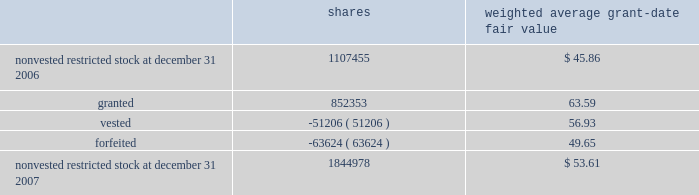Humana inc .
Notes to consolidated financial statements 2014 ( continued ) the total intrinsic value of stock options exercised during 2007 was $ 133.9 million , compared with $ 133.7 million during 2006 and $ 57.8 million during 2005 .
Cash received from stock option exercises for the years ended december 31 , 2007 , 2006 , and 2005 totaled $ 62.7 million , $ 49.2 million , and $ 36.4 million , respectively .
Total compensation expense related to nonvested options not yet recognized was $ 23.6 million at december 31 , 2007 .
We expect to recognize this compensation expense over a weighted average period of approximately 1.6 years .
Restricted stock awards restricted stock awards are granted with a fair value equal to the market price of our common stock on the date of grant .
Compensation expense is recorded straight-line over the vesting period , generally three years from the date of grant .
The weighted average grant date fair value of our restricted stock awards was $ 63.59 , $ 54.36 , and $ 32.81 for the years ended december 31 , 2007 , 2006 , and 2005 , respectively .
Activity for our restricted stock awards was as follows for the year ended december 31 , 2007 : shares weighted average grant-date fair value .
The fair value of shares vested during the years ended december 31 , 2007 , 2006 , and 2005 was $ 3.4 million , $ 2.3 million , and $ 0.6 million , respectively .
Total compensation expense related to nonvested restricted stock awards not yet recognized was $ 44.7 million at december 31 , 2007 .
We expect to recognize this compensation expense over a weighted average period of approximately 1.4 years .
There are no other contractual terms covering restricted stock awards once vested. .
For the year ended december 31 , 2007 what was the ratio of the shares granted to the shares vested? 
Rationale: for the year ended december 31 , 2007 for every 16.65 shares granted 1 shares was vested
Computations: (852353 / 51206)
Answer: 16.64557. 